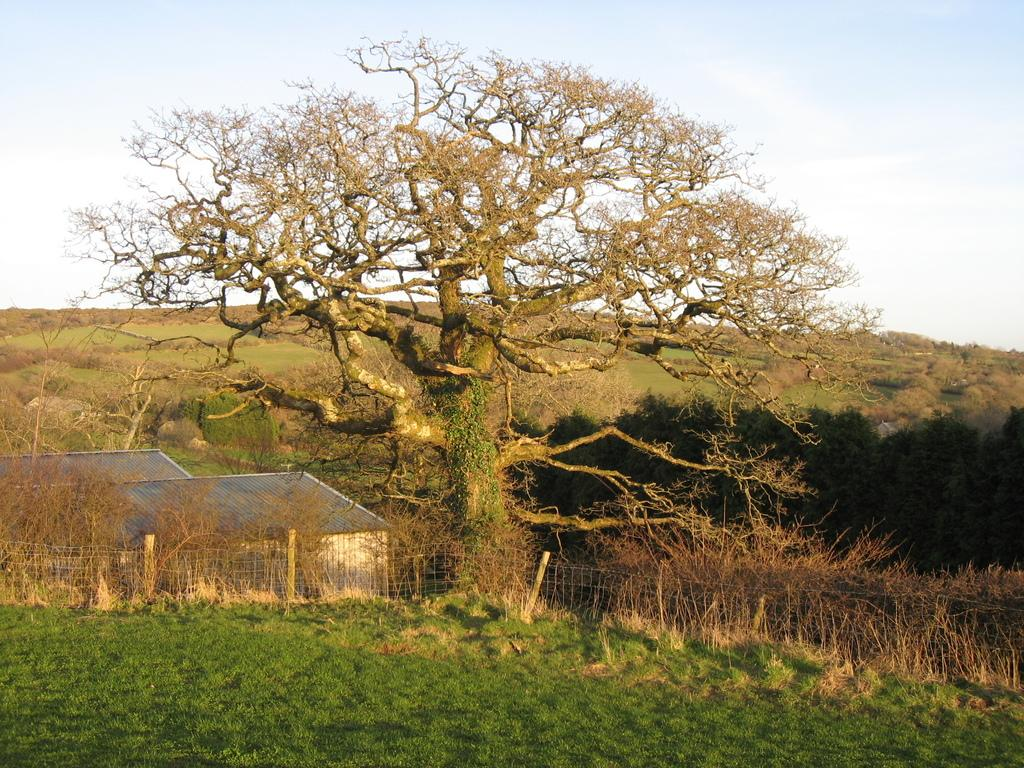What type of vegetation is present in the image? There are trees and grass in the image. What type of structure can be seen in the image? There is a fence with poles in the image. What part of the natural environment is visible in the image? The sky is visible in the image. Can you tell me how many buttons are on the tiger's shirt in the image? There is no tiger or shirt present in the image, let alone a tiger or buttons. 